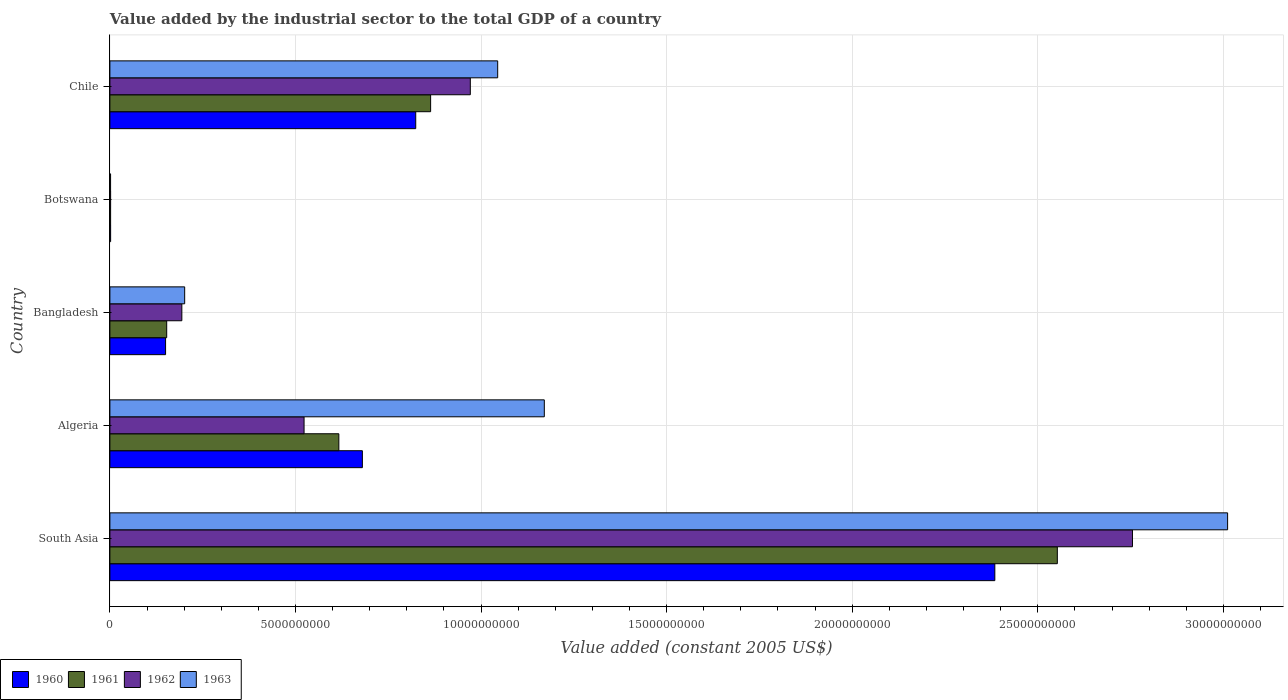How many different coloured bars are there?
Keep it short and to the point. 4. How many bars are there on the 3rd tick from the top?
Your answer should be compact. 4. How many bars are there on the 2nd tick from the bottom?
Ensure brevity in your answer.  4. What is the label of the 1st group of bars from the top?
Your answer should be compact. Chile. In how many cases, is the number of bars for a given country not equal to the number of legend labels?
Offer a very short reply. 0. What is the value added by the industrial sector in 1962 in Botswana?
Provide a short and direct response. 1.98e+07. Across all countries, what is the maximum value added by the industrial sector in 1960?
Your answer should be very brief. 2.38e+1. Across all countries, what is the minimum value added by the industrial sector in 1962?
Your answer should be very brief. 1.98e+07. In which country was the value added by the industrial sector in 1962 minimum?
Offer a very short reply. Botswana. What is the total value added by the industrial sector in 1961 in the graph?
Keep it short and to the point. 4.19e+1. What is the difference between the value added by the industrial sector in 1963 in Algeria and that in Botswana?
Your answer should be compact. 1.17e+1. What is the difference between the value added by the industrial sector in 1963 in Bangladesh and the value added by the industrial sector in 1960 in Algeria?
Offer a very short reply. -4.79e+09. What is the average value added by the industrial sector in 1962 per country?
Your answer should be very brief. 8.89e+09. What is the difference between the value added by the industrial sector in 1960 and value added by the industrial sector in 1963 in Bangladesh?
Provide a succinct answer. -5.14e+08. In how many countries, is the value added by the industrial sector in 1961 greater than 9000000000 US$?
Keep it short and to the point. 1. What is the ratio of the value added by the industrial sector in 1960 in Algeria to that in Botswana?
Ensure brevity in your answer.  346.79. Is the difference between the value added by the industrial sector in 1960 in Bangladesh and Chile greater than the difference between the value added by the industrial sector in 1963 in Bangladesh and Chile?
Keep it short and to the point. Yes. What is the difference between the highest and the second highest value added by the industrial sector in 1961?
Your answer should be compact. 1.69e+1. What is the difference between the highest and the lowest value added by the industrial sector in 1960?
Provide a short and direct response. 2.38e+1. Is it the case that in every country, the sum of the value added by the industrial sector in 1963 and value added by the industrial sector in 1961 is greater than the sum of value added by the industrial sector in 1962 and value added by the industrial sector in 1960?
Make the answer very short. No. What does the 4th bar from the bottom in Botswana represents?
Ensure brevity in your answer.  1963. Is it the case that in every country, the sum of the value added by the industrial sector in 1961 and value added by the industrial sector in 1963 is greater than the value added by the industrial sector in 1960?
Your answer should be compact. Yes. How many bars are there?
Ensure brevity in your answer.  20. How many countries are there in the graph?
Your answer should be very brief. 5. Does the graph contain grids?
Keep it short and to the point. Yes. Where does the legend appear in the graph?
Ensure brevity in your answer.  Bottom left. How are the legend labels stacked?
Your answer should be compact. Horizontal. What is the title of the graph?
Provide a succinct answer. Value added by the industrial sector to the total GDP of a country. What is the label or title of the X-axis?
Ensure brevity in your answer.  Value added (constant 2005 US$). What is the label or title of the Y-axis?
Make the answer very short. Country. What is the Value added (constant 2005 US$) of 1960 in South Asia?
Your answer should be compact. 2.38e+1. What is the Value added (constant 2005 US$) of 1961 in South Asia?
Keep it short and to the point. 2.55e+1. What is the Value added (constant 2005 US$) of 1962 in South Asia?
Your response must be concise. 2.76e+1. What is the Value added (constant 2005 US$) in 1963 in South Asia?
Provide a succinct answer. 3.01e+1. What is the Value added (constant 2005 US$) of 1960 in Algeria?
Your answer should be compact. 6.80e+09. What is the Value added (constant 2005 US$) in 1961 in Algeria?
Provide a short and direct response. 6.17e+09. What is the Value added (constant 2005 US$) in 1962 in Algeria?
Ensure brevity in your answer.  5.23e+09. What is the Value added (constant 2005 US$) in 1963 in Algeria?
Keep it short and to the point. 1.17e+1. What is the Value added (constant 2005 US$) of 1960 in Bangladesh?
Your answer should be compact. 1.50e+09. What is the Value added (constant 2005 US$) of 1961 in Bangladesh?
Provide a short and direct response. 1.53e+09. What is the Value added (constant 2005 US$) of 1962 in Bangladesh?
Offer a terse response. 1.94e+09. What is the Value added (constant 2005 US$) of 1963 in Bangladesh?
Give a very brief answer. 2.01e+09. What is the Value added (constant 2005 US$) of 1960 in Botswana?
Ensure brevity in your answer.  1.96e+07. What is the Value added (constant 2005 US$) in 1961 in Botswana?
Offer a terse response. 1.92e+07. What is the Value added (constant 2005 US$) in 1962 in Botswana?
Your answer should be compact. 1.98e+07. What is the Value added (constant 2005 US$) of 1963 in Botswana?
Offer a very short reply. 1.83e+07. What is the Value added (constant 2005 US$) in 1960 in Chile?
Your answer should be compact. 8.24e+09. What is the Value added (constant 2005 US$) in 1961 in Chile?
Make the answer very short. 8.64e+09. What is the Value added (constant 2005 US$) in 1962 in Chile?
Keep it short and to the point. 9.71e+09. What is the Value added (constant 2005 US$) in 1963 in Chile?
Offer a very short reply. 1.04e+1. Across all countries, what is the maximum Value added (constant 2005 US$) of 1960?
Your answer should be very brief. 2.38e+1. Across all countries, what is the maximum Value added (constant 2005 US$) in 1961?
Offer a terse response. 2.55e+1. Across all countries, what is the maximum Value added (constant 2005 US$) of 1962?
Keep it short and to the point. 2.76e+1. Across all countries, what is the maximum Value added (constant 2005 US$) of 1963?
Offer a very short reply. 3.01e+1. Across all countries, what is the minimum Value added (constant 2005 US$) of 1960?
Ensure brevity in your answer.  1.96e+07. Across all countries, what is the minimum Value added (constant 2005 US$) of 1961?
Keep it short and to the point. 1.92e+07. Across all countries, what is the minimum Value added (constant 2005 US$) of 1962?
Your response must be concise. 1.98e+07. Across all countries, what is the minimum Value added (constant 2005 US$) of 1963?
Keep it short and to the point. 1.83e+07. What is the total Value added (constant 2005 US$) of 1960 in the graph?
Provide a short and direct response. 4.04e+1. What is the total Value added (constant 2005 US$) of 1961 in the graph?
Ensure brevity in your answer.  4.19e+1. What is the total Value added (constant 2005 US$) in 1962 in the graph?
Provide a short and direct response. 4.45e+1. What is the total Value added (constant 2005 US$) of 1963 in the graph?
Your response must be concise. 5.43e+1. What is the difference between the Value added (constant 2005 US$) of 1960 in South Asia and that in Algeria?
Give a very brief answer. 1.70e+1. What is the difference between the Value added (constant 2005 US$) of 1961 in South Asia and that in Algeria?
Your answer should be compact. 1.94e+1. What is the difference between the Value added (constant 2005 US$) in 1962 in South Asia and that in Algeria?
Ensure brevity in your answer.  2.23e+1. What is the difference between the Value added (constant 2005 US$) in 1963 in South Asia and that in Algeria?
Offer a terse response. 1.84e+1. What is the difference between the Value added (constant 2005 US$) in 1960 in South Asia and that in Bangladesh?
Provide a succinct answer. 2.23e+1. What is the difference between the Value added (constant 2005 US$) in 1961 in South Asia and that in Bangladesh?
Provide a succinct answer. 2.40e+1. What is the difference between the Value added (constant 2005 US$) in 1962 in South Asia and that in Bangladesh?
Give a very brief answer. 2.56e+1. What is the difference between the Value added (constant 2005 US$) in 1963 in South Asia and that in Bangladesh?
Your response must be concise. 2.81e+1. What is the difference between the Value added (constant 2005 US$) in 1960 in South Asia and that in Botswana?
Provide a short and direct response. 2.38e+1. What is the difference between the Value added (constant 2005 US$) of 1961 in South Asia and that in Botswana?
Provide a succinct answer. 2.55e+1. What is the difference between the Value added (constant 2005 US$) of 1962 in South Asia and that in Botswana?
Provide a short and direct response. 2.75e+1. What is the difference between the Value added (constant 2005 US$) of 1963 in South Asia and that in Botswana?
Your response must be concise. 3.01e+1. What is the difference between the Value added (constant 2005 US$) of 1960 in South Asia and that in Chile?
Keep it short and to the point. 1.56e+1. What is the difference between the Value added (constant 2005 US$) in 1961 in South Asia and that in Chile?
Your response must be concise. 1.69e+1. What is the difference between the Value added (constant 2005 US$) in 1962 in South Asia and that in Chile?
Your answer should be compact. 1.78e+1. What is the difference between the Value added (constant 2005 US$) in 1963 in South Asia and that in Chile?
Provide a short and direct response. 1.97e+1. What is the difference between the Value added (constant 2005 US$) in 1960 in Algeria and that in Bangladesh?
Make the answer very short. 5.30e+09. What is the difference between the Value added (constant 2005 US$) of 1961 in Algeria and that in Bangladesh?
Provide a short and direct response. 4.64e+09. What is the difference between the Value added (constant 2005 US$) of 1962 in Algeria and that in Bangladesh?
Your answer should be very brief. 3.29e+09. What is the difference between the Value added (constant 2005 US$) in 1963 in Algeria and that in Bangladesh?
Keep it short and to the point. 9.69e+09. What is the difference between the Value added (constant 2005 US$) of 1960 in Algeria and that in Botswana?
Ensure brevity in your answer.  6.78e+09. What is the difference between the Value added (constant 2005 US$) in 1961 in Algeria and that in Botswana?
Your answer should be compact. 6.15e+09. What is the difference between the Value added (constant 2005 US$) of 1962 in Algeria and that in Botswana?
Your response must be concise. 5.21e+09. What is the difference between the Value added (constant 2005 US$) in 1963 in Algeria and that in Botswana?
Your answer should be very brief. 1.17e+1. What is the difference between the Value added (constant 2005 US$) in 1960 in Algeria and that in Chile?
Offer a very short reply. -1.44e+09. What is the difference between the Value added (constant 2005 US$) of 1961 in Algeria and that in Chile?
Provide a short and direct response. -2.47e+09. What is the difference between the Value added (constant 2005 US$) of 1962 in Algeria and that in Chile?
Give a very brief answer. -4.48e+09. What is the difference between the Value added (constant 2005 US$) in 1963 in Algeria and that in Chile?
Offer a terse response. 1.26e+09. What is the difference between the Value added (constant 2005 US$) in 1960 in Bangladesh and that in Botswana?
Offer a very short reply. 1.48e+09. What is the difference between the Value added (constant 2005 US$) of 1961 in Bangladesh and that in Botswana?
Keep it short and to the point. 1.51e+09. What is the difference between the Value added (constant 2005 US$) of 1962 in Bangladesh and that in Botswana?
Your response must be concise. 1.92e+09. What is the difference between the Value added (constant 2005 US$) in 1963 in Bangladesh and that in Botswana?
Ensure brevity in your answer.  2.00e+09. What is the difference between the Value added (constant 2005 US$) of 1960 in Bangladesh and that in Chile?
Offer a very short reply. -6.74e+09. What is the difference between the Value added (constant 2005 US$) in 1961 in Bangladesh and that in Chile?
Provide a succinct answer. -7.11e+09. What is the difference between the Value added (constant 2005 US$) in 1962 in Bangladesh and that in Chile?
Offer a very short reply. -7.77e+09. What is the difference between the Value added (constant 2005 US$) in 1963 in Bangladesh and that in Chile?
Provide a succinct answer. -8.43e+09. What is the difference between the Value added (constant 2005 US$) in 1960 in Botswana and that in Chile?
Give a very brief answer. -8.22e+09. What is the difference between the Value added (constant 2005 US$) of 1961 in Botswana and that in Chile?
Offer a terse response. -8.62e+09. What is the difference between the Value added (constant 2005 US$) of 1962 in Botswana and that in Chile?
Offer a very short reply. -9.69e+09. What is the difference between the Value added (constant 2005 US$) in 1963 in Botswana and that in Chile?
Ensure brevity in your answer.  -1.04e+1. What is the difference between the Value added (constant 2005 US$) in 1960 in South Asia and the Value added (constant 2005 US$) in 1961 in Algeria?
Provide a succinct answer. 1.77e+1. What is the difference between the Value added (constant 2005 US$) in 1960 in South Asia and the Value added (constant 2005 US$) in 1962 in Algeria?
Provide a succinct answer. 1.86e+1. What is the difference between the Value added (constant 2005 US$) in 1960 in South Asia and the Value added (constant 2005 US$) in 1963 in Algeria?
Make the answer very short. 1.21e+1. What is the difference between the Value added (constant 2005 US$) of 1961 in South Asia and the Value added (constant 2005 US$) of 1962 in Algeria?
Provide a succinct answer. 2.03e+1. What is the difference between the Value added (constant 2005 US$) of 1961 in South Asia and the Value added (constant 2005 US$) of 1963 in Algeria?
Make the answer very short. 1.38e+1. What is the difference between the Value added (constant 2005 US$) of 1962 in South Asia and the Value added (constant 2005 US$) of 1963 in Algeria?
Keep it short and to the point. 1.58e+1. What is the difference between the Value added (constant 2005 US$) of 1960 in South Asia and the Value added (constant 2005 US$) of 1961 in Bangladesh?
Your answer should be compact. 2.23e+1. What is the difference between the Value added (constant 2005 US$) in 1960 in South Asia and the Value added (constant 2005 US$) in 1962 in Bangladesh?
Offer a terse response. 2.19e+1. What is the difference between the Value added (constant 2005 US$) of 1960 in South Asia and the Value added (constant 2005 US$) of 1963 in Bangladesh?
Ensure brevity in your answer.  2.18e+1. What is the difference between the Value added (constant 2005 US$) in 1961 in South Asia and the Value added (constant 2005 US$) in 1962 in Bangladesh?
Offer a very short reply. 2.36e+1. What is the difference between the Value added (constant 2005 US$) of 1961 in South Asia and the Value added (constant 2005 US$) of 1963 in Bangladesh?
Offer a very short reply. 2.35e+1. What is the difference between the Value added (constant 2005 US$) in 1962 in South Asia and the Value added (constant 2005 US$) in 1963 in Bangladesh?
Offer a terse response. 2.55e+1. What is the difference between the Value added (constant 2005 US$) of 1960 in South Asia and the Value added (constant 2005 US$) of 1961 in Botswana?
Provide a short and direct response. 2.38e+1. What is the difference between the Value added (constant 2005 US$) in 1960 in South Asia and the Value added (constant 2005 US$) in 1962 in Botswana?
Offer a terse response. 2.38e+1. What is the difference between the Value added (constant 2005 US$) in 1960 in South Asia and the Value added (constant 2005 US$) in 1963 in Botswana?
Keep it short and to the point. 2.38e+1. What is the difference between the Value added (constant 2005 US$) in 1961 in South Asia and the Value added (constant 2005 US$) in 1962 in Botswana?
Make the answer very short. 2.55e+1. What is the difference between the Value added (constant 2005 US$) of 1961 in South Asia and the Value added (constant 2005 US$) of 1963 in Botswana?
Your answer should be compact. 2.55e+1. What is the difference between the Value added (constant 2005 US$) in 1962 in South Asia and the Value added (constant 2005 US$) in 1963 in Botswana?
Make the answer very short. 2.75e+1. What is the difference between the Value added (constant 2005 US$) of 1960 in South Asia and the Value added (constant 2005 US$) of 1961 in Chile?
Provide a succinct answer. 1.52e+1. What is the difference between the Value added (constant 2005 US$) of 1960 in South Asia and the Value added (constant 2005 US$) of 1962 in Chile?
Offer a very short reply. 1.41e+1. What is the difference between the Value added (constant 2005 US$) of 1960 in South Asia and the Value added (constant 2005 US$) of 1963 in Chile?
Offer a terse response. 1.34e+1. What is the difference between the Value added (constant 2005 US$) in 1961 in South Asia and the Value added (constant 2005 US$) in 1962 in Chile?
Give a very brief answer. 1.58e+1. What is the difference between the Value added (constant 2005 US$) in 1961 in South Asia and the Value added (constant 2005 US$) in 1963 in Chile?
Provide a succinct answer. 1.51e+1. What is the difference between the Value added (constant 2005 US$) of 1962 in South Asia and the Value added (constant 2005 US$) of 1963 in Chile?
Keep it short and to the point. 1.71e+1. What is the difference between the Value added (constant 2005 US$) of 1960 in Algeria and the Value added (constant 2005 US$) of 1961 in Bangladesh?
Your answer should be very brief. 5.27e+09. What is the difference between the Value added (constant 2005 US$) in 1960 in Algeria and the Value added (constant 2005 US$) in 1962 in Bangladesh?
Offer a terse response. 4.86e+09. What is the difference between the Value added (constant 2005 US$) of 1960 in Algeria and the Value added (constant 2005 US$) of 1963 in Bangladesh?
Your response must be concise. 4.79e+09. What is the difference between the Value added (constant 2005 US$) in 1961 in Algeria and the Value added (constant 2005 US$) in 1962 in Bangladesh?
Give a very brief answer. 4.23e+09. What is the difference between the Value added (constant 2005 US$) of 1961 in Algeria and the Value added (constant 2005 US$) of 1963 in Bangladesh?
Provide a short and direct response. 4.15e+09. What is the difference between the Value added (constant 2005 US$) in 1962 in Algeria and the Value added (constant 2005 US$) in 1963 in Bangladesh?
Your response must be concise. 3.22e+09. What is the difference between the Value added (constant 2005 US$) in 1960 in Algeria and the Value added (constant 2005 US$) in 1961 in Botswana?
Keep it short and to the point. 6.78e+09. What is the difference between the Value added (constant 2005 US$) of 1960 in Algeria and the Value added (constant 2005 US$) of 1962 in Botswana?
Provide a succinct answer. 6.78e+09. What is the difference between the Value added (constant 2005 US$) of 1960 in Algeria and the Value added (constant 2005 US$) of 1963 in Botswana?
Your answer should be compact. 6.78e+09. What is the difference between the Value added (constant 2005 US$) in 1961 in Algeria and the Value added (constant 2005 US$) in 1962 in Botswana?
Your response must be concise. 6.15e+09. What is the difference between the Value added (constant 2005 US$) in 1961 in Algeria and the Value added (constant 2005 US$) in 1963 in Botswana?
Give a very brief answer. 6.15e+09. What is the difference between the Value added (constant 2005 US$) in 1962 in Algeria and the Value added (constant 2005 US$) in 1963 in Botswana?
Your answer should be compact. 5.21e+09. What is the difference between the Value added (constant 2005 US$) in 1960 in Algeria and the Value added (constant 2005 US$) in 1961 in Chile?
Offer a terse response. -1.84e+09. What is the difference between the Value added (constant 2005 US$) of 1960 in Algeria and the Value added (constant 2005 US$) of 1962 in Chile?
Offer a very short reply. -2.91e+09. What is the difference between the Value added (constant 2005 US$) in 1960 in Algeria and the Value added (constant 2005 US$) in 1963 in Chile?
Your answer should be very brief. -3.65e+09. What is the difference between the Value added (constant 2005 US$) in 1961 in Algeria and the Value added (constant 2005 US$) in 1962 in Chile?
Make the answer very short. -3.54e+09. What is the difference between the Value added (constant 2005 US$) in 1961 in Algeria and the Value added (constant 2005 US$) in 1963 in Chile?
Provide a succinct answer. -4.28e+09. What is the difference between the Value added (constant 2005 US$) in 1962 in Algeria and the Value added (constant 2005 US$) in 1963 in Chile?
Your answer should be very brief. -5.22e+09. What is the difference between the Value added (constant 2005 US$) in 1960 in Bangladesh and the Value added (constant 2005 US$) in 1961 in Botswana?
Your answer should be very brief. 1.48e+09. What is the difference between the Value added (constant 2005 US$) in 1960 in Bangladesh and the Value added (constant 2005 US$) in 1962 in Botswana?
Offer a very short reply. 1.48e+09. What is the difference between the Value added (constant 2005 US$) in 1960 in Bangladesh and the Value added (constant 2005 US$) in 1963 in Botswana?
Your response must be concise. 1.48e+09. What is the difference between the Value added (constant 2005 US$) in 1961 in Bangladesh and the Value added (constant 2005 US$) in 1962 in Botswana?
Give a very brief answer. 1.51e+09. What is the difference between the Value added (constant 2005 US$) of 1961 in Bangladesh and the Value added (constant 2005 US$) of 1963 in Botswana?
Provide a short and direct response. 1.51e+09. What is the difference between the Value added (constant 2005 US$) of 1962 in Bangladesh and the Value added (constant 2005 US$) of 1963 in Botswana?
Your answer should be very brief. 1.92e+09. What is the difference between the Value added (constant 2005 US$) in 1960 in Bangladesh and the Value added (constant 2005 US$) in 1961 in Chile?
Make the answer very short. -7.14e+09. What is the difference between the Value added (constant 2005 US$) in 1960 in Bangladesh and the Value added (constant 2005 US$) in 1962 in Chile?
Your answer should be very brief. -8.21e+09. What is the difference between the Value added (constant 2005 US$) of 1960 in Bangladesh and the Value added (constant 2005 US$) of 1963 in Chile?
Provide a succinct answer. -8.95e+09. What is the difference between the Value added (constant 2005 US$) in 1961 in Bangladesh and the Value added (constant 2005 US$) in 1962 in Chile?
Your response must be concise. -8.18e+09. What is the difference between the Value added (constant 2005 US$) in 1961 in Bangladesh and the Value added (constant 2005 US$) in 1963 in Chile?
Ensure brevity in your answer.  -8.92e+09. What is the difference between the Value added (constant 2005 US$) of 1962 in Bangladesh and the Value added (constant 2005 US$) of 1963 in Chile?
Your response must be concise. -8.51e+09. What is the difference between the Value added (constant 2005 US$) of 1960 in Botswana and the Value added (constant 2005 US$) of 1961 in Chile?
Offer a terse response. -8.62e+09. What is the difference between the Value added (constant 2005 US$) of 1960 in Botswana and the Value added (constant 2005 US$) of 1962 in Chile?
Offer a very short reply. -9.69e+09. What is the difference between the Value added (constant 2005 US$) in 1960 in Botswana and the Value added (constant 2005 US$) in 1963 in Chile?
Your answer should be compact. -1.04e+1. What is the difference between the Value added (constant 2005 US$) of 1961 in Botswana and the Value added (constant 2005 US$) of 1962 in Chile?
Your answer should be very brief. -9.69e+09. What is the difference between the Value added (constant 2005 US$) in 1961 in Botswana and the Value added (constant 2005 US$) in 1963 in Chile?
Offer a terse response. -1.04e+1. What is the difference between the Value added (constant 2005 US$) in 1962 in Botswana and the Value added (constant 2005 US$) in 1963 in Chile?
Give a very brief answer. -1.04e+1. What is the average Value added (constant 2005 US$) of 1960 per country?
Ensure brevity in your answer.  8.08e+09. What is the average Value added (constant 2005 US$) in 1961 per country?
Keep it short and to the point. 8.38e+09. What is the average Value added (constant 2005 US$) in 1962 per country?
Your answer should be very brief. 8.89e+09. What is the average Value added (constant 2005 US$) in 1963 per country?
Your answer should be compact. 1.09e+1. What is the difference between the Value added (constant 2005 US$) in 1960 and Value added (constant 2005 US$) in 1961 in South Asia?
Give a very brief answer. -1.68e+09. What is the difference between the Value added (constant 2005 US$) of 1960 and Value added (constant 2005 US$) of 1962 in South Asia?
Give a very brief answer. -3.71e+09. What is the difference between the Value added (constant 2005 US$) of 1960 and Value added (constant 2005 US$) of 1963 in South Asia?
Ensure brevity in your answer.  -6.27e+09. What is the difference between the Value added (constant 2005 US$) of 1961 and Value added (constant 2005 US$) of 1962 in South Asia?
Make the answer very short. -2.02e+09. What is the difference between the Value added (constant 2005 US$) in 1961 and Value added (constant 2005 US$) in 1963 in South Asia?
Your answer should be very brief. -4.59e+09. What is the difference between the Value added (constant 2005 US$) of 1962 and Value added (constant 2005 US$) of 1963 in South Asia?
Provide a short and direct response. -2.56e+09. What is the difference between the Value added (constant 2005 US$) in 1960 and Value added (constant 2005 US$) in 1961 in Algeria?
Make the answer very short. 6.34e+08. What is the difference between the Value added (constant 2005 US$) in 1960 and Value added (constant 2005 US$) in 1962 in Algeria?
Make the answer very short. 1.57e+09. What is the difference between the Value added (constant 2005 US$) of 1960 and Value added (constant 2005 US$) of 1963 in Algeria?
Offer a terse response. -4.90e+09. What is the difference between the Value added (constant 2005 US$) in 1961 and Value added (constant 2005 US$) in 1962 in Algeria?
Your response must be concise. 9.37e+08. What is the difference between the Value added (constant 2005 US$) in 1961 and Value added (constant 2005 US$) in 1963 in Algeria?
Your answer should be very brief. -5.54e+09. What is the difference between the Value added (constant 2005 US$) in 1962 and Value added (constant 2005 US$) in 1963 in Algeria?
Provide a succinct answer. -6.47e+09. What is the difference between the Value added (constant 2005 US$) in 1960 and Value added (constant 2005 US$) in 1961 in Bangladesh?
Offer a very short reply. -3.05e+07. What is the difference between the Value added (constant 2005 US$) of 1960 and Value added (constant 2005 US$) of 1962 in Bangladesh?
Your answer should be very brief. -4.38e+08. What is the difference between the Value added (constant 2005 US$) in 1960 and Value added (constant 2005 US$) in 1963 in Bangladesh?
Ensure brevity in your answer.  -5.14e+08. What is the difference between the Value added (constant 2005 US$) in 1961 and Value added (constant 2005 US$) in 1962 in Bangladesh?
Make the answer very short. -4.08e+08. What is the difference between the Value added (constant 2005 US$) of 1961 and Value added (constant 2005 US$) of 1963 in Bangladesh?
Your answer should be compact. -4.84e+08. What is the difference between the Value added (constant 2005 US$) of 1962 and Value added (constant 2005 US$) of 1963 in Bangladesh?
Make the answer very short. -7.60e+07. What is the difference between the Value added (constant 2005 US$) of 1960 and Value added (constant 2005 US$) of 1961 in Botswana?
Your answer should be compact. 4.24e+05. What is the difference between the Value added (constant 2005 US$) in 1960 and Value added (constant 2005 US$) in 1962 in Botswana?
Give a very brief answer. -2.12e+05. What is the difference between the Value added (constant 2005 US$) in 1960 and Value added (constant 2005 US$) in 1963 in Botswana?
Make the answer very short. 1.27e+06. What is the difference between the Value added (constant 2005 US$) of 1961 and Value added (constant 2005 US$) of 1962 in Botswana?
Offer a terse response. -6.36e+05. What is the difference between the Value added (constant 2005 US$) of 1961 and Value added (constant 2005 US$) of 1963 in Botswana?
Your response must be concise. 8.48e+05. What is the difference between the Value added (constant 2005 US$) in 1962 and Value added (constant 2005 US$) in 1963 in Botswana?
Your response must be concise. 1.48e+06. What is the difference between the Value added (constant 2005 US$) in 1960 and Value added (constant 2005 US$) in 1961 in Chile?
Keep it short and to the point. -4.01e+08. What is the difference between the Value added (constant 2005 US$) in 1960 and Value added (constant 2005 US$) in 1962 in Chile?
Make the answer very short. -1.47e+09. What is the difference between the Value added (constant 2005 US$) in 1960 and Value added (constant 2005 US$) in 1963 in Chile?
Your answer should be compact. -2.21e+09. What is the difference between the Value added (constant 2005 US$) in 1961 and Value added (constant 2005 US$) in 1962 in Chile?
Your answer should be compact. -1.07e+09. What is the difference between the Value added (constant 2005 US$) of 1961 and Value added (constant 2005 US$) of 1963 in Chile?
Make the answer very short. -1.81e+09. What is the difference between the Value added (constant 2005 US$) of 1962 and Value added (constant 2005 US$) of 1963 in Chile?
Your answer should be very brief. -7.37e+08. What is the ratio of the Value added (constant 2005 US$) in 1960 in South Asia to that in Algeria?
Make the answer very short. 3.5. What is the ratio of the Value added (constant 2005 US$) of 1961 in South Asia to that in Algeria?
Give a very brief answer. 4.14. What is the ratio of the Value added (constant 2005 US$) in 1962 in South Asia to that in Algeria?
Your answer should be very brief. 5.27. What is the ratio of the Value added (constant 2005 US$) of 1963 in South Asia to that in Algeria?
Your answer should be compact. 2.57. What is the ratio of the Value added (constant 2005 US$) in 1960 in South Asia to that in Bangladesh?
Offer a very short reply. 15.89. What is the ratio of the Value added (constant 2005 US$) of 1961 in South Asia to that in Bangladesh?
Your answer should be compact. 16.68. What is the ratio of the Value added (constant 2005 US$) of 1962 in South Asia to that in Bangladesh?
Provide a short and direct response. 14.21. What is the ratio of the Value added (constant 2005 US$) in 1963 in South Asia to that in Bangladesh?
Offer a terse response. 14.95. What is the ratio of the Value added (constant 2005 US$) in 1960 in South Asia to that in Botswana?
Provide a succinct answer. 1215.49. What is the ratio of the Value added (constant 2005 US$) in 1961 in South Asia to that in Botswana?
Offer a very short reply. 1330.08. What is the ratio of the Value added (constant 2005 US$) of 1962 in South Asia to that in Botswana?
Your answer should be compact. 1389.51. What is the ratio of the Value added (constant 2005 US$) of 1963 in South Asia to that in Botswana?
Your response must be concise. 1641.69. What is the ratio of the Value added (constant 2005 US$) in 1960 in South Asia to that in Chile?
Ensure brevity in your answer.  2.89. What is the ratio of the Value added (constant 2005 US$) of 1961 in South Asia to that in Chile?
Make the answer very short. 2.95. What is the ratio of the Value added (constant 2005 US$) of 1962 in South Asia to that in Chile?
Make the answer very short. 2.84. What is the ratio of the Value added (constant 2005 US$) of 1963 in South Asia to that in Chile?
Offer a very short reply. 2.88. What is the ratio of the Value added (constant 2005 US$) in 1960 in Algeria to that in Bangladesh?
Your response must be concise. 4.53. What is the ratio of the Value added (constant 2005 US$) in 1961 in Algeria to that in Bangladesh?
Your answer should be very brief. 4.03. What is the ratio of the Value added (constant 2005 US$) in 1962 in Algeria to that in Bangladesh?
Keep it short and to the point. 2.7. What is the ratio of the Value added (constant 2005 US$) of 1963 in Algeria to that in Bangladesh?
Provide a short and direct response. 5.81. What is the ratio of the Value added (constant 2005 US$) of 1960 in Algeria to that in Botswana?
Offer a terse response. 346.79. What is the ratio of the Value added (constant 2005 US$) of 1961 in Algeria to that in Botswana?
Your response must be concise. 321.41. What is the ratio of the Value added (constant 2005 US$) in 1962 in Algeria to that in Botswana?
Ensure brevity in your answer.  263.85. What is the ratio of the Value added (constant 2005 US$) of 1963 in Algeria to that in Botswana?
Give a very brief answer. 638.08. What is the ratio of the Value added (constant 2005 US$) of 1960 in Algeria to that in Chile?
Ensure brevity in your answer.  0.83. What is the ratio of the Value added (constant 2005 US$) in 1961 in Algeria to that in Chile?
Provide a short and direct response. 0.71. What is the ratio of the Value added (constant 2005 US$) of 1962 in Algeria to that in Chile?
Ensure brevity in your answer.  0.54. What is the ratio of the Value added (constant 2005 US$) of 1963 in Algeria to that in Chile?
Your answer should be very brief. 1.12. What is the ratio of the Value added (constant 2005 US$) of 1960 in Bangladesh to that in Botswana?
Make the answer very short. 76.48. What is the ratio of the Value added (constant 2005 US$) in 1961 in Bangladesh to that in Botswana?
Give a very brief answer. 79.76. What is the ratio of the Value added (constant 2005 US$) of 1962 in Bangladesh to that in Botswana?
Keep it short and to the point. 97.78. What is the ratio of the Value added (constant 2005 US$) in 1963 in Bangladesh to that in Botswana?
Your response must be concise. 109.83. What is the ratio of the Value added (constant 2005 US$) of 1960 in Bangladesh to that in Chile?
Provide a succinct answer. 0.18. What is the ratio of the Value added (constant 2005 US$) in 1961 in Bangladesh to that in Chile?
Your response must be concise. 0.18. What is the ratio of the Value added (constant 2005 US$) in 1962 in Bangladesh to that in Chile?
Offer a very short reply. 0.2. What is the ratio of the Value added (constant 2005 US$) of 1963 in Bangladesh to that in Chile?
Make the answer very short. 0.19. What is the ratio of the Value added (constant 2005 US$) in 1960 in Botswana to that in Chile?
Offer a very short reply. 0. What is the ratio of the Value added (constant 2005 US$) of 1961 in Botswana to that in Chile?
Your answer should be very brief. 0. What is the ratio of the Value added (constant 2005 US$) in 1962 in Botswana to that in Chile?
Offer a terse response. 0. What is the ratio of the Value added (constant 2005 US$) in 1963 in Botswana to that in Chile?
Give a very brief answer. 0. What is the difference between the highest and the second highest Value added (constant 2005 US$) of 1960?
Your response must be concise. 1.56e+1. What is the difference between the highest and the second highest Value added (constant 2005 US$) of 1961?
Offer a very short reply. 1.69e+1. What is the difference between the highest and the second highest Value added (constant 2005 US$) of 1962?
Your response must be concise. 1.78e+1. What is the difference between the highest and the second highest Value added (constant 2005 US$) in 1963?
Ensure brevity in your answer.  1.84e+1. What is the difference between the highest and the lowest Value added (constant 2005 US$) in 1960?
Your answer should be compact. 2.38e+1. What is the difference between the highest and the lowest Value added (constant 2005 US$) of 1961?
Offer a terse response. 2.55e+1. What is the difference between the highest and the lowest Value added (constant 2005 US$) in 1962?
Keep it short and to the point. 2.75e+1. What is the difference between the highest and the lowest Value added (constant 2005 US$) of 1963?
Give a very brief answer. 3.01e+1. 